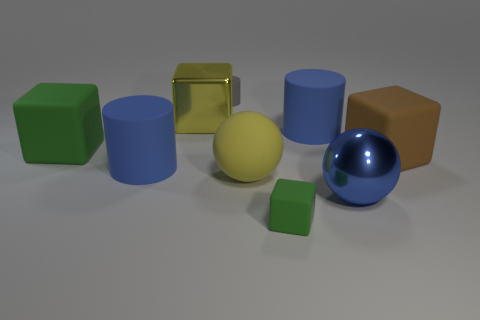Is the color of the matte ball the same as the shiny block?
Your answer should be very brief. Yes. What shape is the large shiny object that is the same color as the matte ball?
Make the answer very short. Cube. There is a blue matte cylinder to the right of the tiny green matte object; does it have the same size as the thing that is right of the big blue metallic ball?
Keep it short and to the point. Yes. What number of objects are either brown matte cubes or things to the left of the brown thing?
Offer a very short reply. 9. The small rubber cube has what color?
Your answer should be compact. Green. The yellow object that is behind the big brown object right of the big sphere behind the big blue sphere is made of what material?
Your answer should be compact. Metal. What size is the gray object that is the same material as the large brown cube?
Ensure brevity in your answer.  Small. Is there a object of the same color as the big rubber sphere?
Give a very brief answer. Yes. There is a gray cylinder; is it the same size as the green rubber thing that is in front of the brown block?
Your answer should be very brief. Yes. How many blue matte things are on the left side of the gray matte thing that is behind the big blue cylinder to the left of the yellow matte ball?
Your response must be concise. 1. 